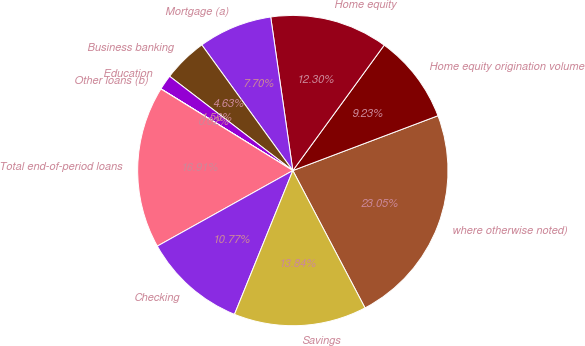Convert chart. <chart><loc_0><loc_0><loc_500><loc_500><pie_chart><fcel>where otherwise noted)<fcel>Home equity origination volume<fcel>Home equity<fcel>Mortgage (a)<fcel>Business banking<fcel>Education<fcel>Other loans (b)<fcel>Total end-of-period loans<fcel>Checking<fcel>Savings<nl><fcel>23.05%<fcel>9.23%<fcel>12.3%<fcel>7.7%<fcel>4.63%<fcel>1.56%<fcel>0.02%<fcel>16.91%<fcel>10.77%<fcel>13.84%<nl></chart> 